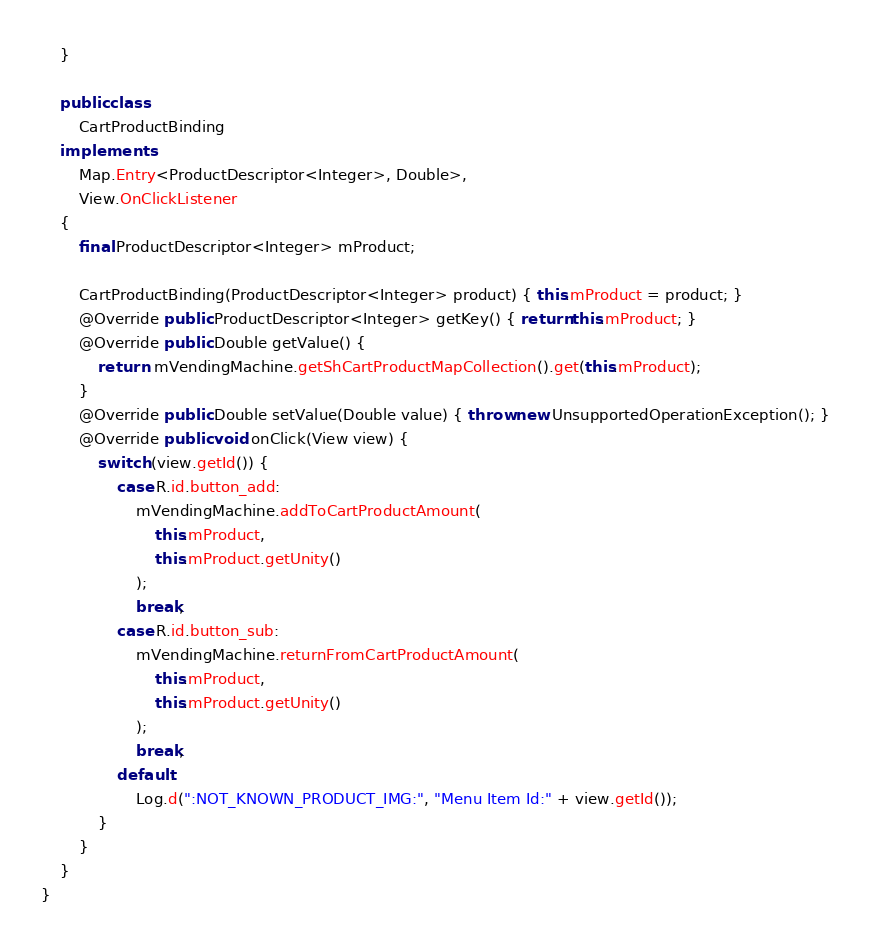<code> <loc_0><loc_0><loc_500><loc_500><_Java_>	}

	public class
		CartProductBinding
	implements
		Map.Entry<ProductDescriptor<Integer>, Double>,
		View.OnClickListener
	{
		final ProductDescriptor<Integer> mProduct;

		CartProductBinding(ProductDescriptor<Integer> product) { this.mProduct = product; }
		@Override public ProductDescriptor<Integer> getKey() { return this.mProduct; }
		@Override public Double getValue() {
			return  mVendingMachine.getShCartProductMapCollection().get(this.mProduct);
		}
		@Override public Double setValue(Double value) { throw new UnsupportedOperationException(); }
		@Override public void onClick(View view) {
			switch (view.getId()) {
				case R.id.button_add:
					mVendingMachine.addToCartProductAmount(
						this.mProduct,
						this.mProduct.getUnity()
					);
					break;
				case R.id.button_sub:
					mVendingMachine.returnFromCartProductAmount(
						this.mProduct,
						this.mProduct.getUnity()
					);
					break;
				default:
					Log.d(":NOT_KNOWN_PRODUCT_IMG:", "Menu Item Id:" + view.getId());
			}
		}
	}
}</code> 